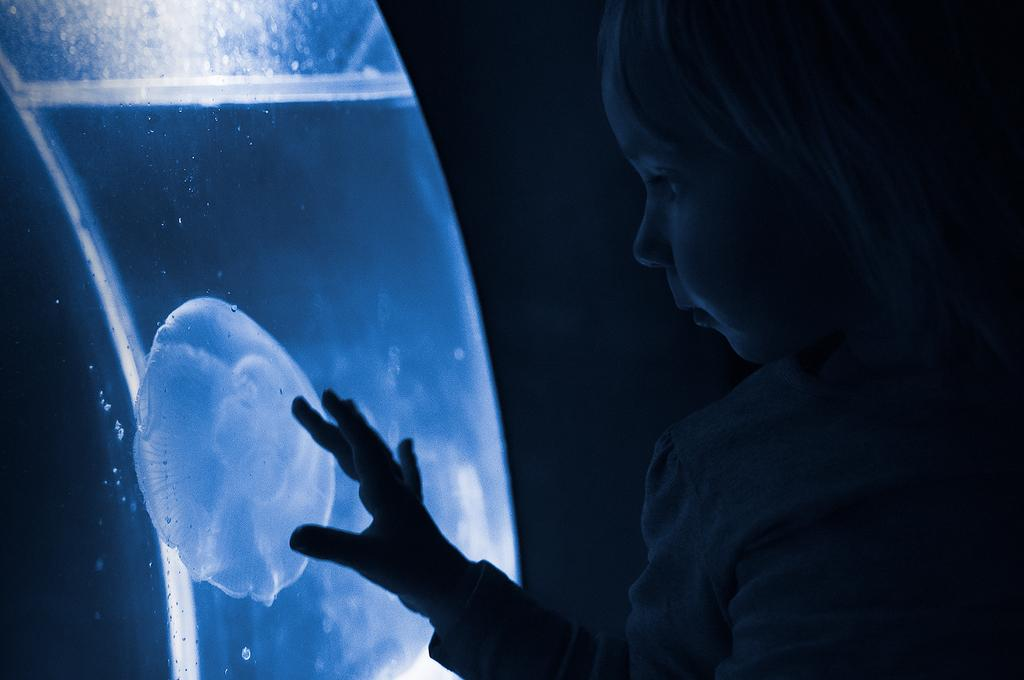Where is the kid located in the image? The kid is on the right side of the image. What can be seen on the left side of the image? There is an aquatic animal in an aquarium on the left side of the image. What is the color of the background in the image? The background of the image is dark. How many statements are visible in the image? There are no statements present in the image. What type of seat can be seen in the image? There is no seat present in the image. 